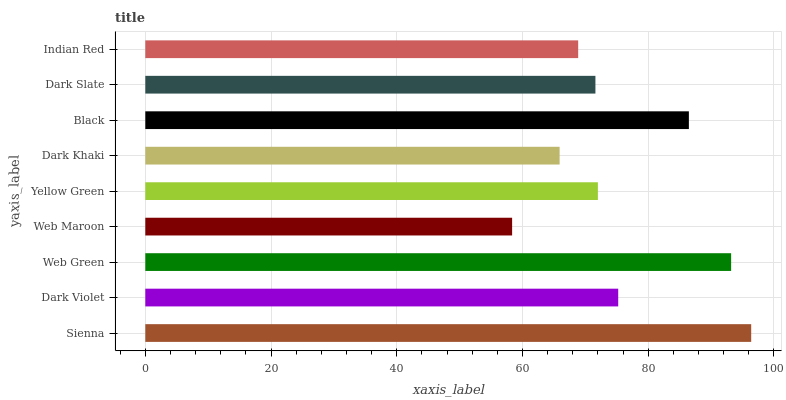Is Web Maroon the minimum?
Answer yes or no. Yes. Is Sienna the maximum?
Answer yes or no. Yes. Is Dark Violet the minimum?
Answer yes or no. No. Is Dark Violet the maximum?
Answer yes or no. No. Is Sienna greater than Dark Violet?
Answer yes or no. Yes. Is Dark Violet less than Sienna?
Answer yes or no. Yes. Is Dark Violet greater than Sienna?
Answer yes or no. No. Is Sienna less than Dark Violet?
Answer yes or no. No. Is Yellow Green the high median?
Answer yes or no. Yes. Is Yellow Green the low median?
Answer yes or no. Yes. Is Indian Red the high median?
Answer yes or no. No. Is Dark Violet the low median?
Answer yes or no. No. 